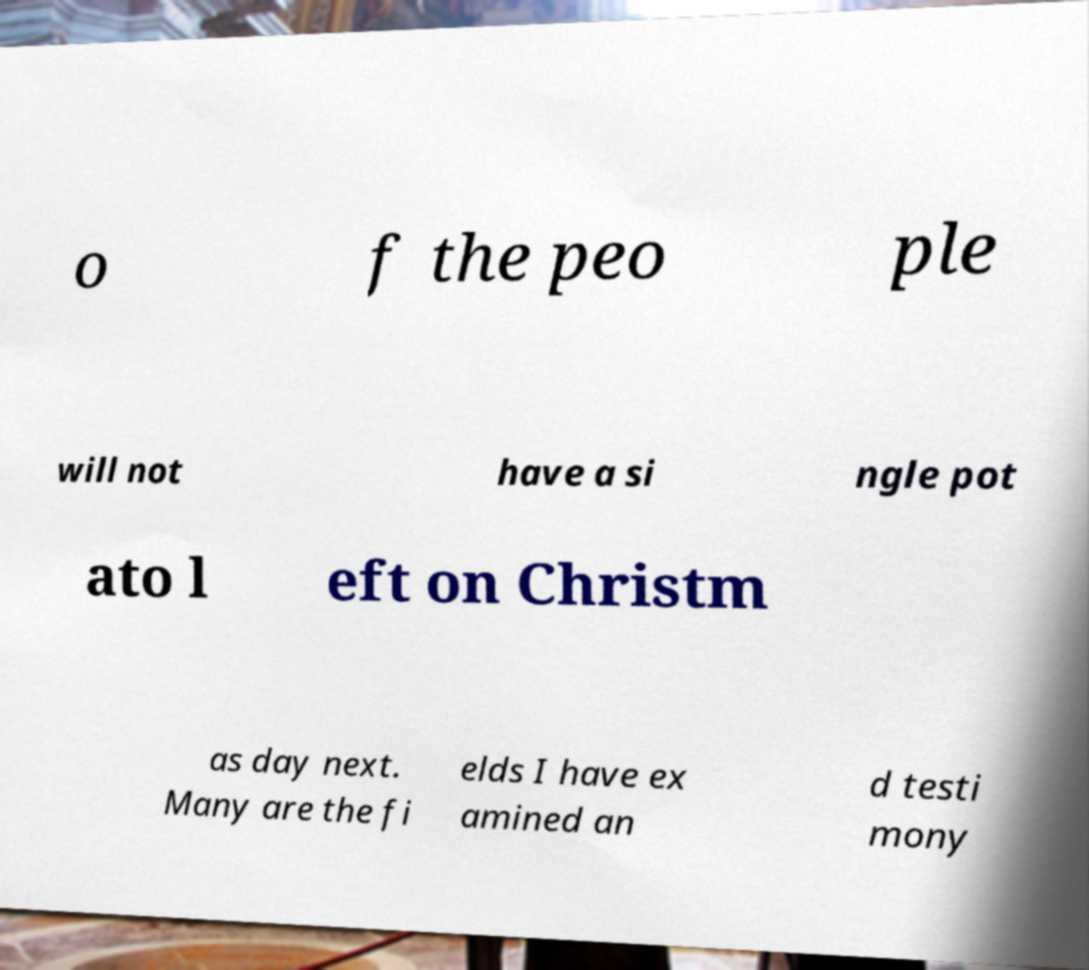Could you extract and type out the text from this image? o f the peo ple will not have a si ngle pot ato l eft on Christm as day next. Many are the fi elds I have ex amined an d testi mony 